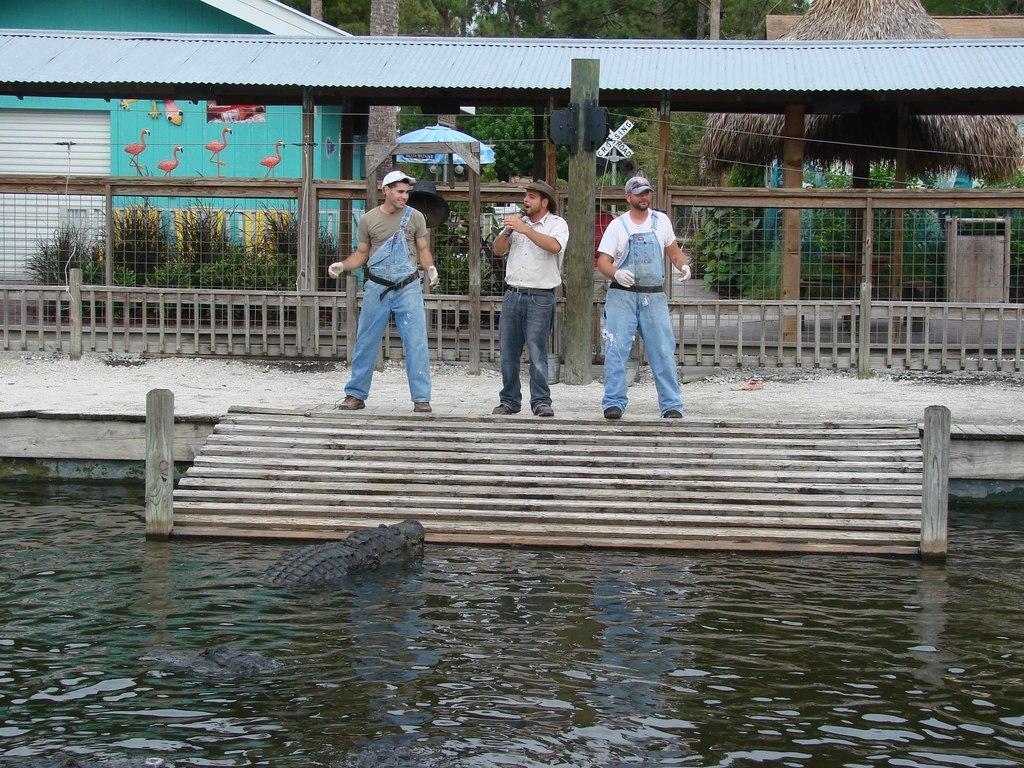How would you summarize this image in a sentence or two? In this image three people are standing on the floor, having staircase. Bottom of the image there is a crocodile in the water. Middle of the image there is a person holding a mike and he is wearing a cap. Behind them there is a fence. Behind there are few plants, houses. There is an umbrella. Background there are few trees. 